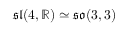<formula> <loc_0><loc_0><loc_500><loc_500>{ \mathfrak { s l } } ( 4 , \mathbb { R } ) \simeq { \mathfrak { s o } } ( 3 , 3 )</formula> 